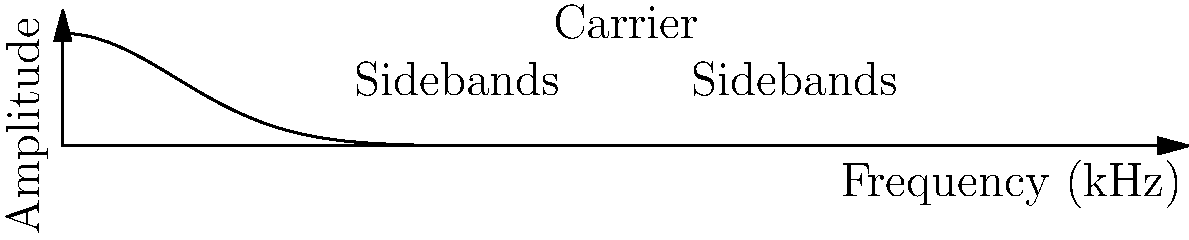In this AM radio frequency spectrum, what is the approximate bandwidth of the signal, assuming the carrier frequency is at 5 kHz? To determine the bandwidth of an AM signal from its frequency spectrum, follow these steps:

1. Identify the carrier frequency, which is the central peak (5 kHz in this case).

2. Observe the sidebands, which are the smaller peaks on either side of the carrier. These represent the modulated information.

3. Measure the total width of the signal, from the lowest to the highest frequency component with significant amplitude. In this graph, we can see that the sidebands extend approximately 2 kHz on either side of the carrier.

4. The bandwidth is the difference between the highest and lowest frequency components. In this case, it's about 4 kHz (2 kHz below the carrier to 2 kHz above the carrier).

5. For AM radio, the bandwidth is typically twice the highest modulating frequency. So, if the bandwidth is 4 kHz, the highest audio frequency being transmitted is about 2 kHz.

This bandwidth is consistent with typical AM radio broadcasts, which usually have audio limited to about 5 kHz or less to fit within the allocated channel spacing.
Answer: 4 kHz 